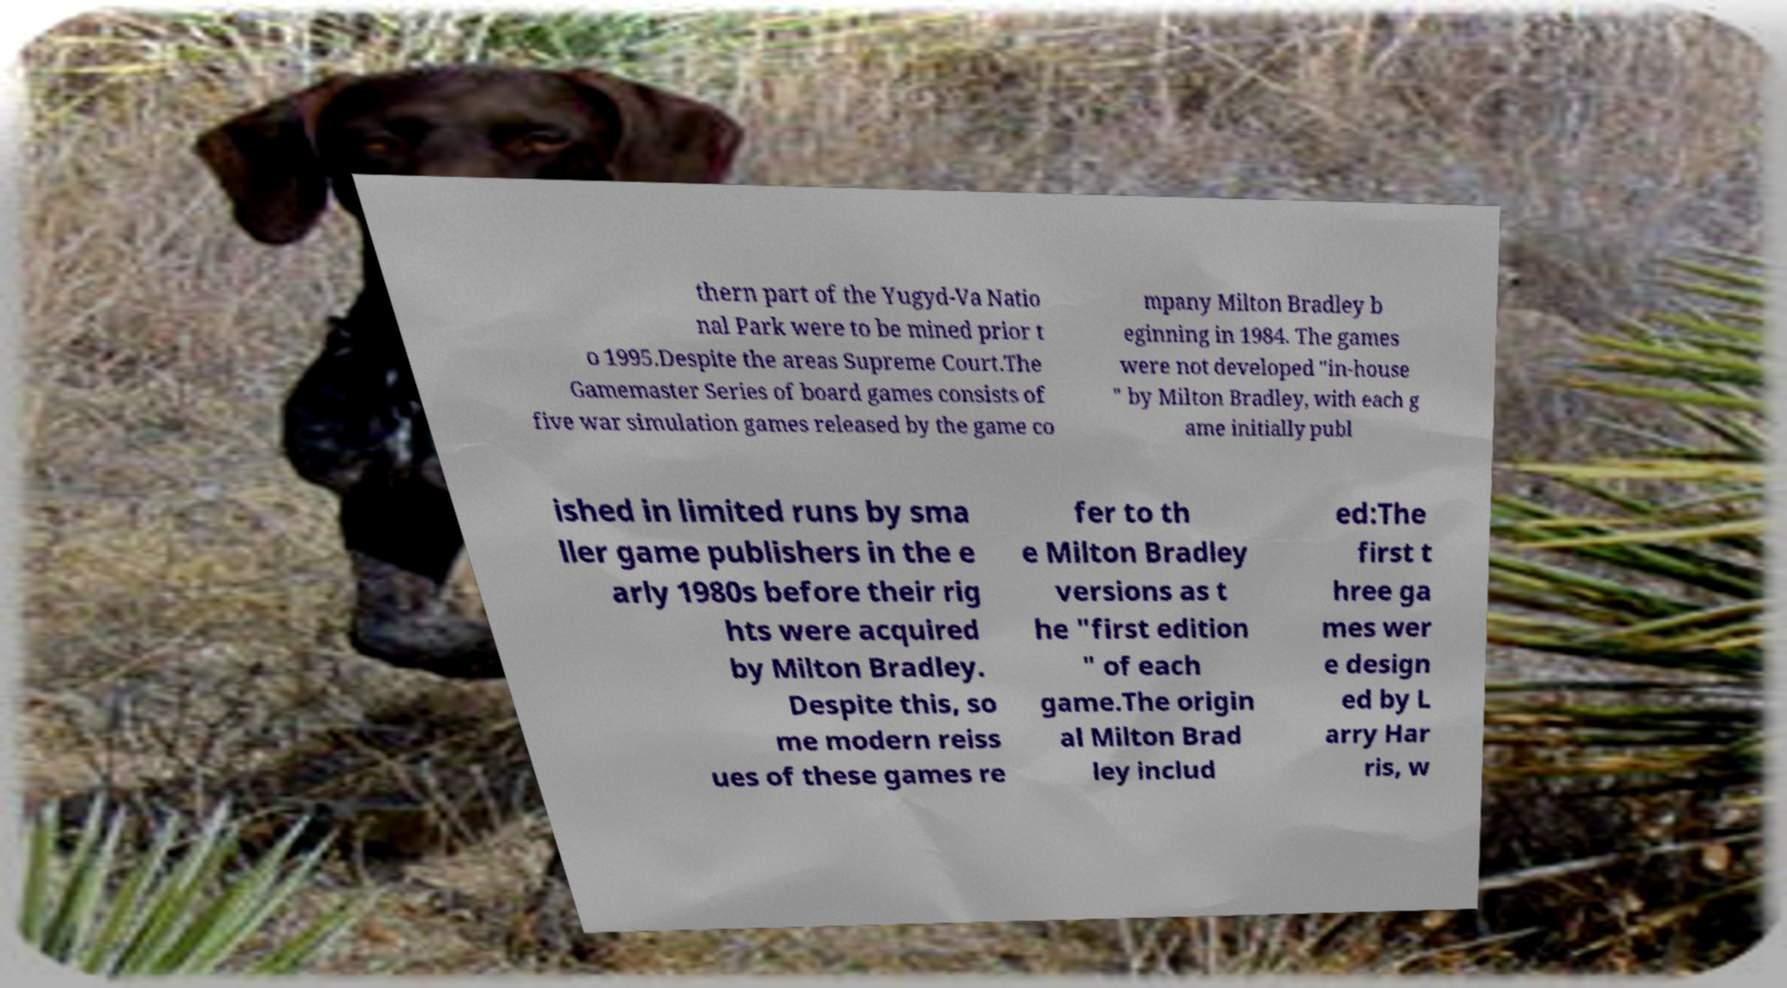Could you extract and type out the text from this image? thern part of the Yugyd-Va Natio nal Park were to be mined prior t o 1995.Despite the areas Supreme Court.The Gamemaster Series of board games consists of five war simulation games released by the game co mpany Milton Bradley b eginning in 1984. The games were not developed "in-house " by Milton Bradley, with each g ame initially publ ished in limited runs by sma ller game publishers in the e arly 1980s before their rig hts were acquired by Milton Bradley. Despite this, so me modern reiss ues of these games re fer to th e Milton Bradley versions as t he "first edition " of each game.The origin al Milton Brad ley includ ed:The first t hree ga mes wer e design ed by L arry Har ris, w 